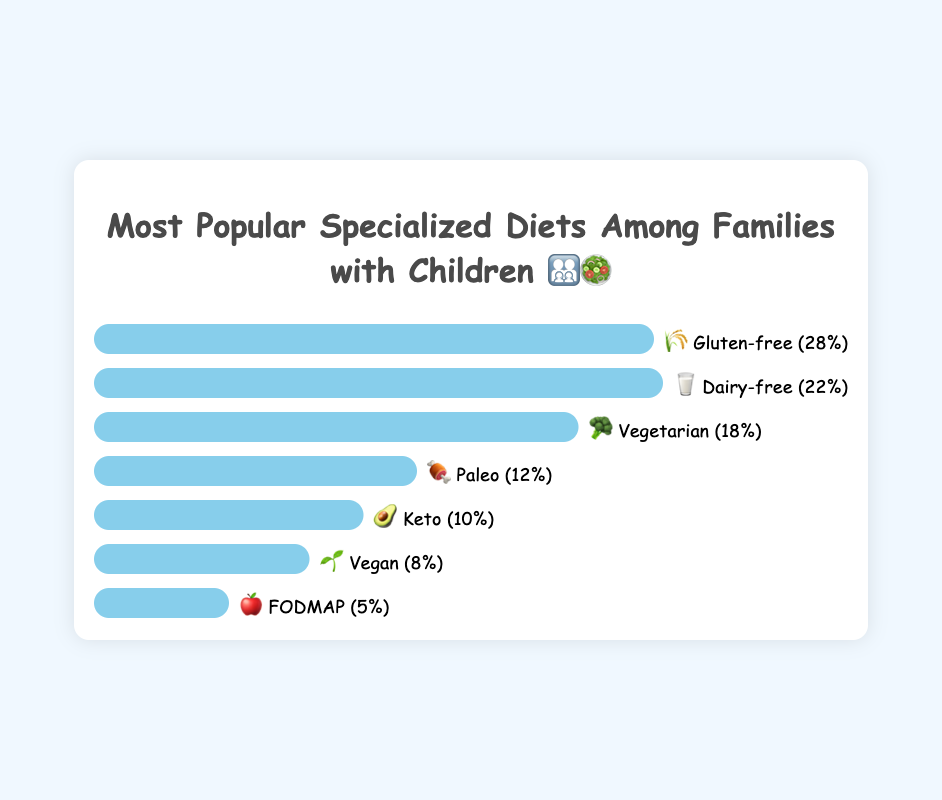What’s the combined popularity percentage of the dairy-free and vegetarian diets? Sum the popularity percentages of the Dairy-free (22%) and Vegetarian (18%) diets. 22 + 18 = 40%
Answer: 40% What is the popularity difference between the Vegan 🌱 and Keto 🥑 diets? Subtract the popularity of the Vegan diet (8%) from the Keto diet (10%). 10 - 8 = 2%
Answer: 2% If the popularity of the top 3 diets were to increase by 5% each, what would be the new popularity percentage for the Vegetarian diet? Add 5% to the current popularity of the Vegetarian diet (18%). 18 + 5 = 23%
Answer: 23% Among the given diets, which one has the least popularity? Identify the diet with the shortest bar on the chart; it is FODMAP with 5%.
Answer: FODMAP 🍎 Rank the diets from highest to lowest popularity. Based on the bar lengths and percentages: Gluten-free, Dairy-free, Vegetarian, Paleo, Keto, Vegan, FODMAP.
Answer: Gluten-free, Dairy-free, Vegetarian, Paleo, Keto, Vegan, FODMAP What's the average popularity percentage of all the diets? Add up all the popularity percentages and divide by the number of diets. (28 + 22 + 18 + 12 + 10 + 8 + 5) / 7 = 103 / 7 ≈ 14.71%
Answer: 14.71% 